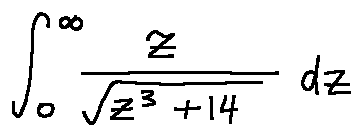<formula> <loc_0><loc_0><loc_500><loc_500>\int \lim i t s _ { 0 } ^ { \infty } \frac { z } { \sqrt { z ^ { 3 } + 1 4 } } d z</formula> 